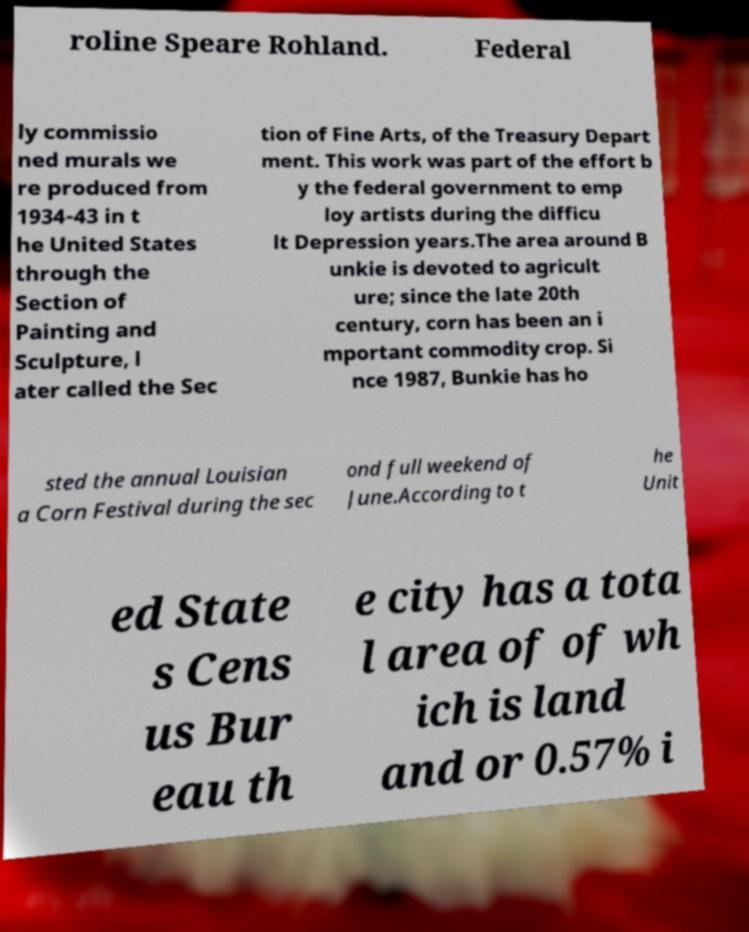Could you assist in decoding the text presented in this image and type it out clearly? roline Speare Rohland. Federal ly commissio ned murals we re produced from 1934-43 in t he United States through the Section of Painting and Sculpture, l ater called the Sec tion of Fine Arts, of the Treasury Depart ment. This work was part of the effort b y the federal government to emp loy artists during the difficu lt Depression years.The area around B unkie is devoted to agricult ure; since the late 20th century, corn has been an i mportant commodity crop. Si nce 1987, Bunkie has ho sted the annual Louisian a Corn Festival during the sec ond full weekend of June.According to t he Unit ed State s Cens us Bur eau th e city has a tota l area of of wh ich is land and or 0.57% i 